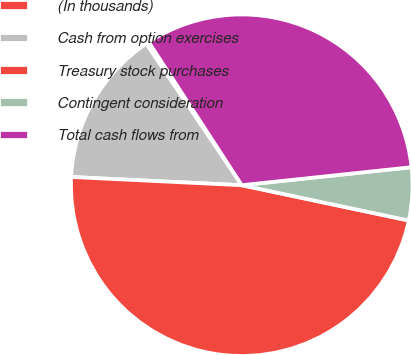<chart> <loc_0><loc_0><loc_500><loc_500><pie_chart><fcel>(In thousands)<fcel>Cash from option exercises<fcel>Treasury stock purchases<fcel>Contingent consideration<fcel>Total cash flows from<nl><fcel>0.28%<fcel>14.78%<fcel>47.46%<fcel>5.0%<fcel>32.49%<nl></chart> 